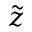Convert formula to latex. <formula><loc_0><loc_0><loc_500><loc_500>\tilde { z }</formula> 